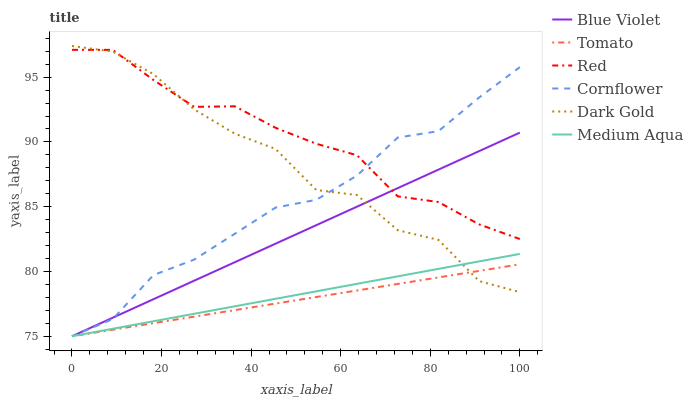Does Tomato have the minimum area under the curve?
Answer yes or no. Yes. Does Red have the maximum area under the curve?
Answer yes or no. Yes. Does Cornflower have the minimum area under the curve?
Answer yes or no. No. Does Cornflower have the maximum area under the curve?
Answer yes or no. No. Is Tomato the smoothest?
Answer yes or no. Yes. Is Dark Gold the roughest?
Answer yes or no. Yes. Is Cornflower the smoothest?
Answer yes or no. No. Is Cornflower the roughest?
Answer yes or no. No. Does Tomato have the lowest value?
Answer yes or no. Yes. Does Dark Gold have the lowest value?
Answer yes or no. No. Does Dark Gold have the highest value?
Answer yes or no. Yes. Does Cornflower have the highest value?
Answer yes or no. No. Is Medium Aqua less than Red?
Answer yes or no. Yes. Is Red greater than Medium Aqua?
Answer yes or no. Yes. Does Tomato intersect Medium Aqua?
Answer yes or no. Yes. Is Tomato less than Medium Aqua?
Answer yes or no. No. Is Tomato greater than Medium Aqua?
Answer yes or no. No. Does Medium Aqua intersect Red?
Answer yes or no. No. 